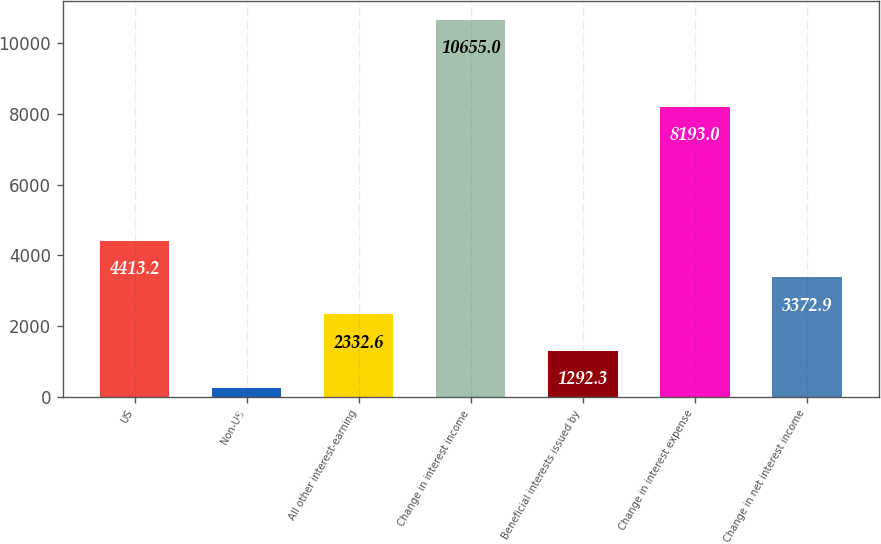Convert chart to OTSL. <chart><loc_0><loc_0><loc_500><loc_500><bar_chart><fcel>US<fcel>Non-US<fcel>All other interest-earning<fcel>Change in interest income<fcel>Beneficial interests issued by<fcel>Change in interest expense<fcel>Change in net interest income<nl><fcel>4413.2<fcel>252<fcel>2332.6<fcel>10655<fcel>1292.3<fcel>8193<fcel>3372.9<nl></chart> 